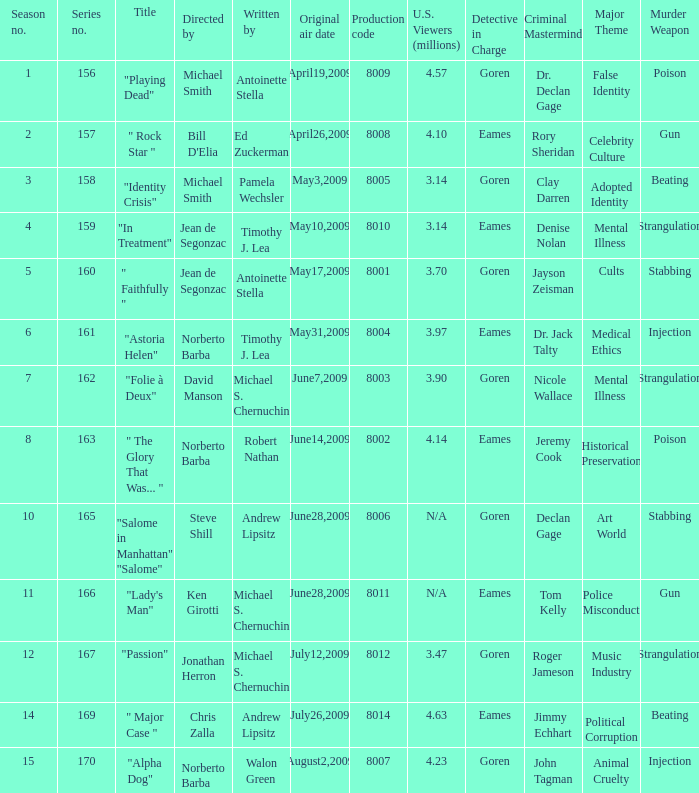Which is the  maximun serie episode number when the millions of north american spectators is 3.14? 159.0. 